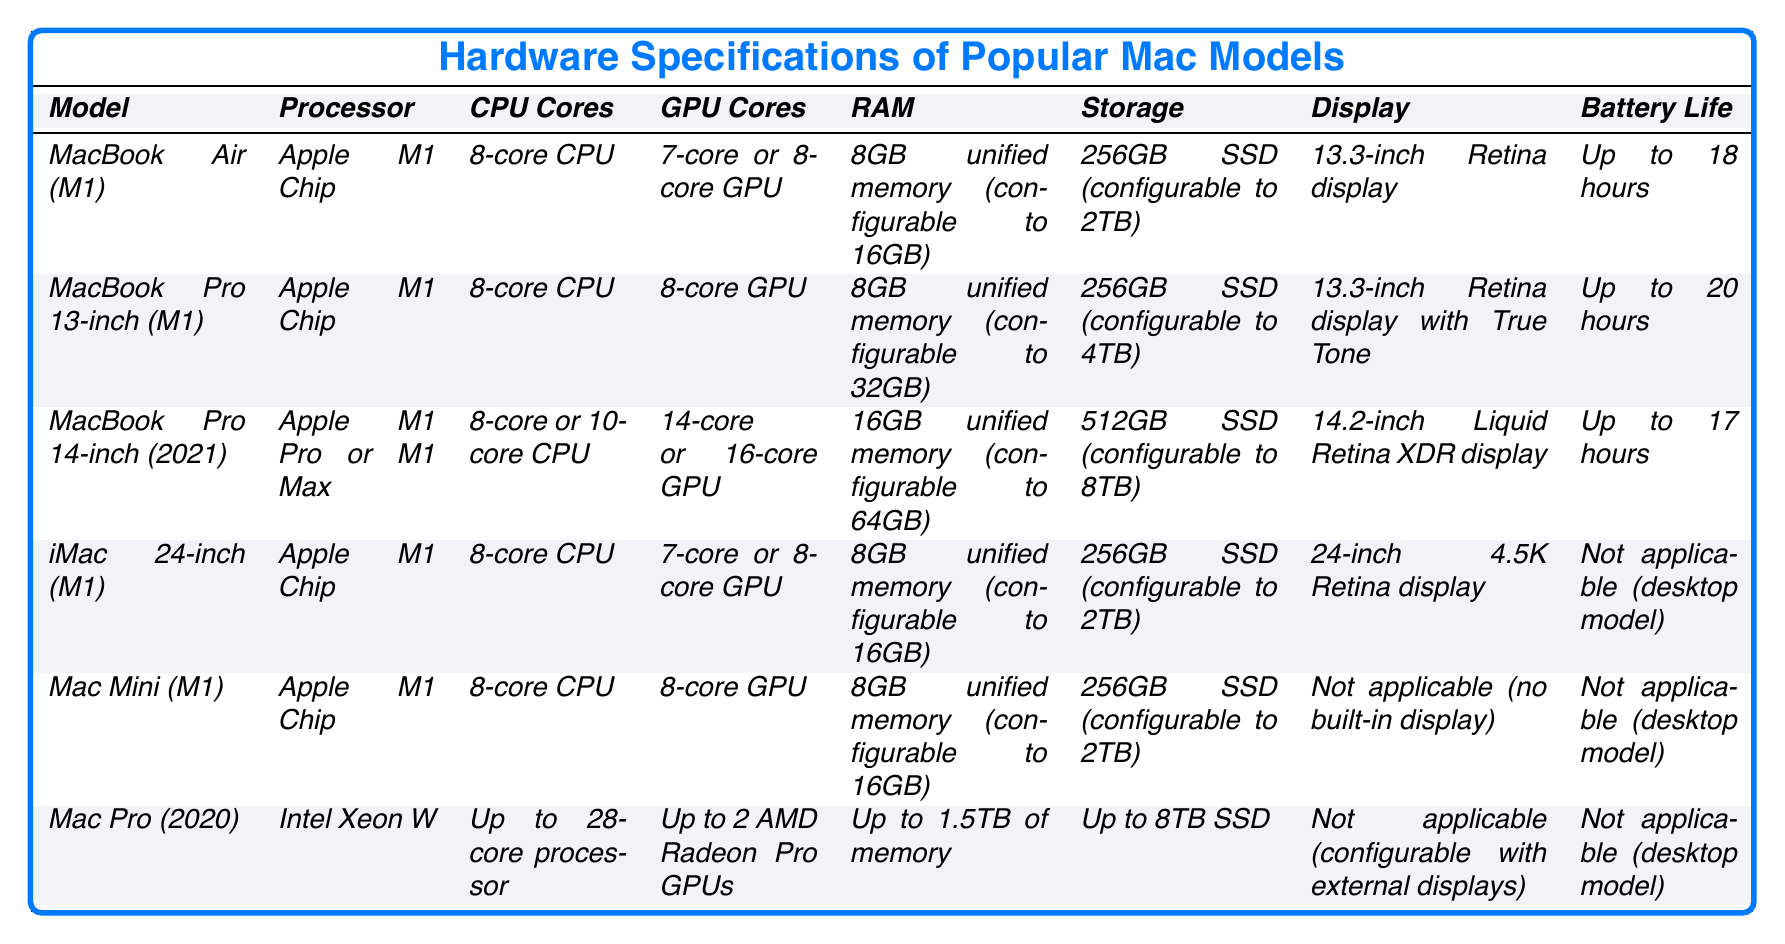What is the battery life of the MacBook Pro 13-inch (M1)? According to the table, the battery life of the MacBook Pro 13-inch (M1) is stated directly as "Up to 20 hours."
Answer: Up to 20 hours Which Mac model has the highest configurable RAM? Referring to the table, the Mac Pro (2020) offers "Up to 1.5TB of memory," which is the highest among all listed models.
Answer: Up to 1.5TB Is the 14-inch MacBook Pro available with the M1 Chip? The table indicates that the 14-inch MacBook Pro (2021) features the "Apple M1 Pro or M1 Max," meaning it does not come with the standard M1 Chip.
Answer: No What is the difference in battery life between the MacBook Air (M1) and the MacBook Pro 14-inch (2021)? The MacBook Air (M1) has a battery life of "Up to 18 hours," while the MacBook Pro 14-inch (2021) has "Up to 17 hours." The difference is calculated as follows: 18 - 17 = 1 hour less for the MacBook Pro.
Answer: 1 hour Which models can be configured with 32GB or more of RAM? The table shows that the MacBook Pro 13-inch (M1) can be configured to 32GB RAM, and the MacBook Pro 14-inch (2021) can be configured to 64GB RAM. No other models listed support this capacity.
Answer: MacBook Pro 13-inch (M1) and MacBook Pro 14-inch (2021) What is the total storage capacity available for the Mac Pro (2020)? The table states that the Mac Pro (2020) storage can be configured "Up to 8TB SSD."
Answer: Up to 8TB SSD Does the iMac 24-inch (M1) have a longer battery life than the Mac Mini (M1)? The table indicates that the iMac 24-inch (M1) has "Not applicable (desktop model)" for battery life, as does the Mac Mini (M1). Therefore, both lack a traditional battery life comparison.
Answer: No comparison possible How many GPU cores does the MacBook Pro 14-inch (2021) offer at maximum? The table presents that the MacBook Pro 14-inch (2021) can have up to "16-core GPU."
Answer: 16-core GPU What is the average display size of the MacBook Air (M1) and MacBook Pro 13-inch (M1)? From the table, the MacBook Air (M1) has a display size of "13.3-inch," and the MacBook Pro 13-inch (M1) also has "13.3-inch." Thus, the average display size is calculated as: (13.3 + 13.3) / 2 = 13.3 inches.
Answer: 13.3 inches Which model provides the option to have dual GPUs? According to the table, the Mac Pro (2020) can be configured with "Up to 2 AMD Radeon Pro GPUs," making it the only model that offers this option.
Answer: Mac Pro (2020) 